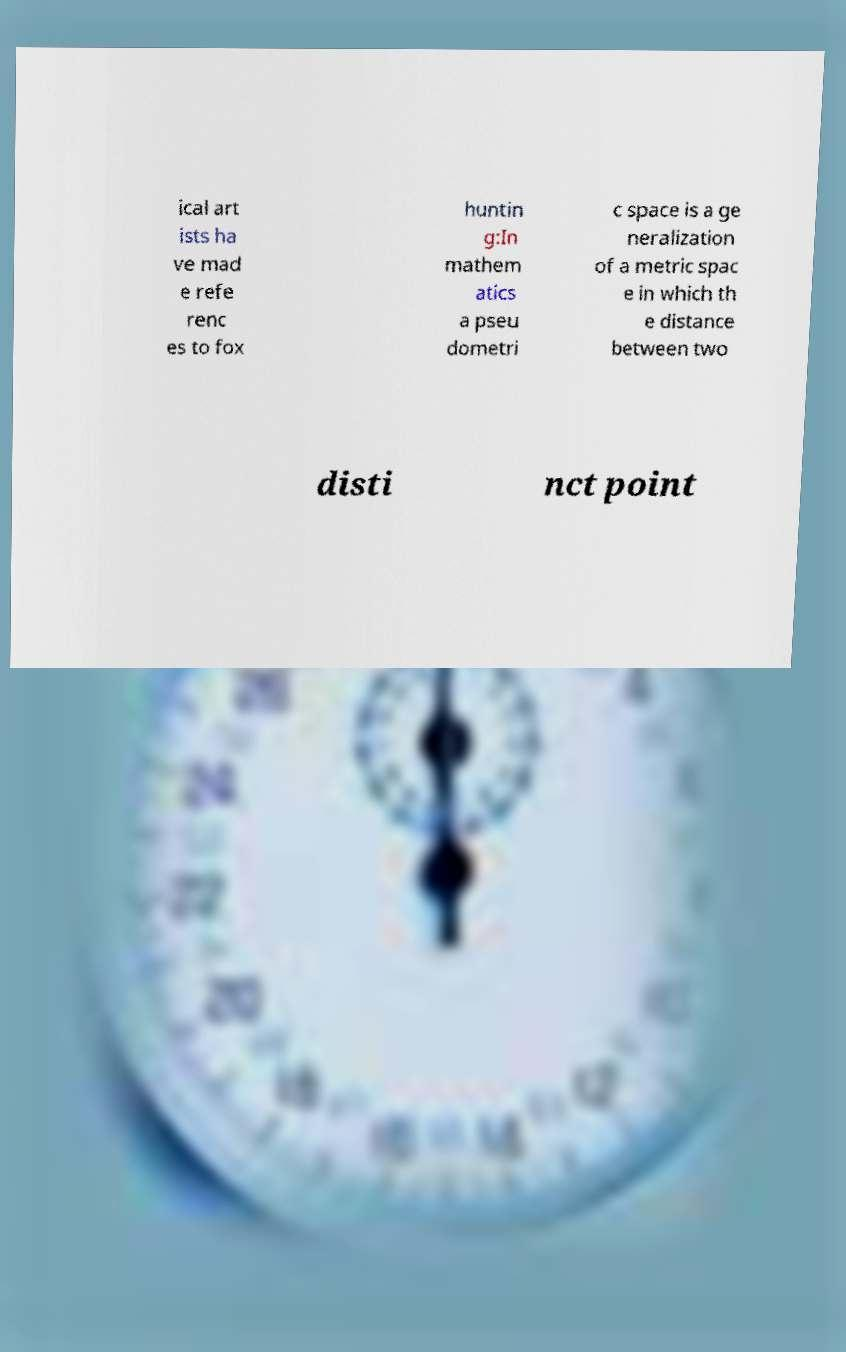Please identify and transcribe the text found in this image. ical art ists ha ve mad e refe renc es to fox huntin g:In mathem atics a pseu dometri c space is a ge neralization of a metric spac e in which th e distance between two disti nct point 